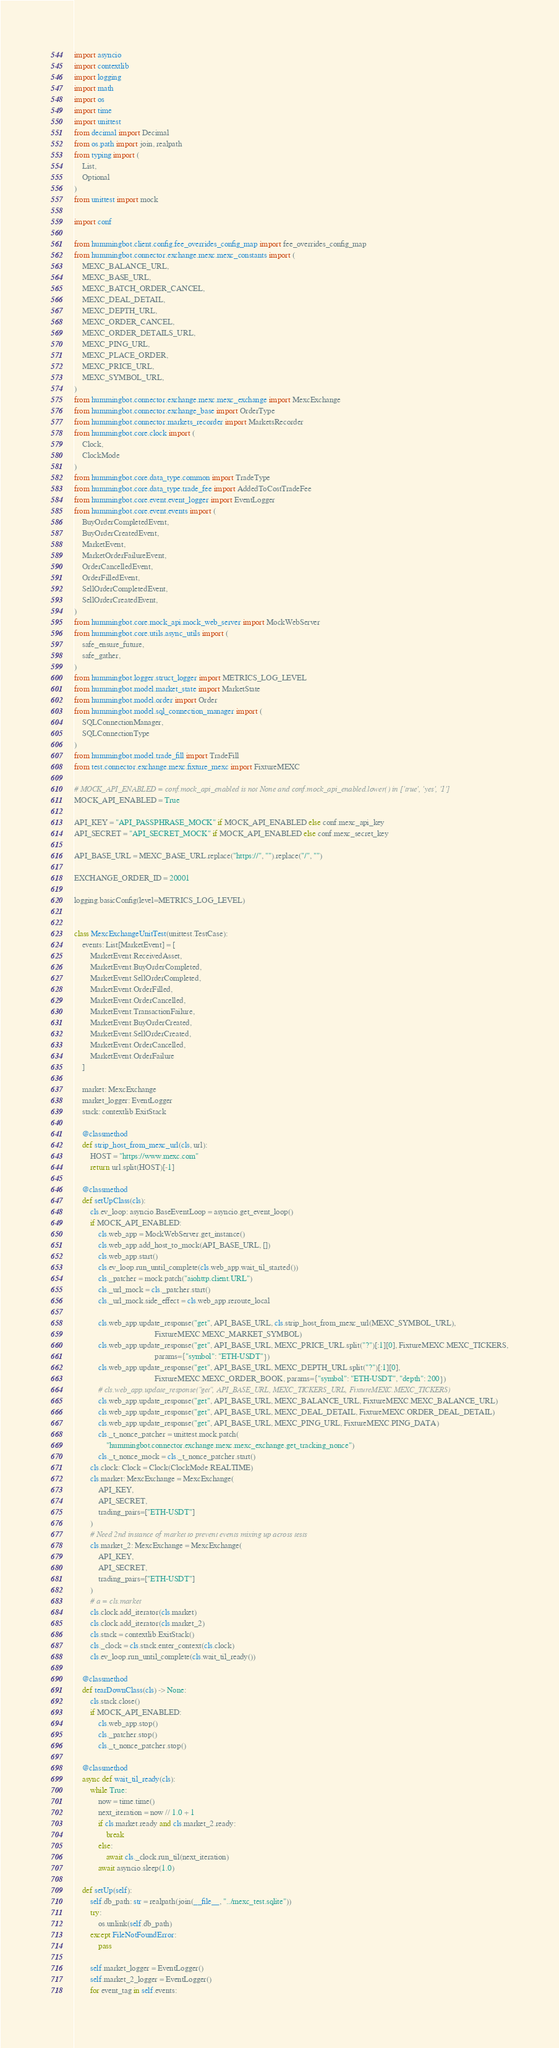<code> <loc_0><loc_0><loc_500><loc_500><_Python_>import asyncio
import contextlib
import logging
import math
import os
import time
import unittest
from decimal import Decimal
from os.path import join, realpath
from typing import (
    List,
    Optional
)
from unittest import mock

import conf

from hummingbot.client.config.fee_overrides_config_map import fee_overrides_config_map
from hummingbot.connector.exchange.mexc.mexc_constants import (
    MEXC_BALANCE_URL,
    MEXC_BASE_URL,
    MEXC_BATCH_ORDER_CANCEL,
    MEXC_DEAL_DETAIL,
    MEXC_DEPTH_URL,
    MEXC_ORDER_CANCEL,
    MEXC_ORDER_DETAILS_URL,
    MEXC_PING_URL,
    MEXC_PLACE_ORDER,
    MEXC_PRICE_URL,
    MEXC_SYMBOL_URL,
)
from hummingbot.connector.exchange.mexc.mexc_exchange import MexcExchange
from hummingbot.connector.exchange_base import OrderType
from hummingbot.connector.markets_recorder import MarketsRecorder
from hummingbot.core.clock import (
    Clock,
    ClockMode
)
from hummingbot.core.data_type.common import TradeType
from hummingbot.core.data_type.trade_fee import AddedToCostTradeFee
from hummingbot.core.event.event_logger import EventLogger
from hummingbot.core.event.events import (
    BuyOrderCompletedEvent,
    BuyOrderCreatedEvent,
    MarketEvent,
    MarketOrderFailureEvent,
    OrderCancelledEvent,
    OrderFilledEvent,
    SellOrderCompletedEvent,
    SellOrderCreatedEvent,
)
from hummingbot.core.mock_api.mock_web_server import MockWebServer
from hummingbot.core.utils.async_utils import (
    safe_ensure_future,
    safe_gather,
)
from hummingbot.logger.struct_logger import METRICS_LOG_LEVEL
from hummingbot.model.market_state import MarketState
from hummingbot.model.order import Order
from hummingbot.model.sql_connection_manager import (
    SQLConnectionManager,
    SQLConnectionType
)
from hummingbot.model.trade_fill import TradeFill
from test.connector.exchange.mexc.fixture_mexc import FixtureMEXC

# MOCK_API_ENABLED = conf.mock_api_enabled is not None and conf.mock_api_enabled.lower() in ['true', 'yes', '1']
MOCK_API_ENABLED = True

API_KEY = "API_PASSPHRASE_MOCK" if MOCK_API_ENABLED else conf.mexc_api_key
API_SECRET = "API_SECRET_MOCK" if MOCK_API_ENABLED else conf.mexc_secret_key

API_BASE_URL = MEXC_BASE_URL.replace("https://", "").replace("/", "")

EXCHANGE_ORDER_ID = 20001

logging.basicConfig(level=METRICS_LOG_LEVEL)


class MexcExchangeUnitTest(unittest.TestCase):
    events: List[MarketEvent] = [
        MarketEvent.ReceivedAsset,
        MarketEvent.BuyOrderCompleted,
        MarketEvent.SellOrderCompleted,
        MarketEvent.OrderFilled,
        MarketEvent.OrderCancelled,
        MarketEvent.TransactionFailure,
        MarketEvent.BuyOrderCreated,
        MarketEvent.SellOrderCreated,
        MarketEvent.OrderCancelled,
        MarketEvent.OrderFailure
    ]

    market: MexcExchange
    market_logger: EventLogger
    stack: contextlib.ExitStack

    @classmethod
    def strip_host_from_mexc_url(cls, url):
        HOST = "https://www.mexc.com"
        return url.split(HOST)[-1]

    @classmethod
    def setUpClass(cls):
        cls.ev_loop: asyncio.BaseEventLoop = asyncio.get_event_loop()
        if MOCK_API_ENABLED:
            cls.web_app = MockWebServer.get_instance()
            cls.web_app.add_host_to_mock(API_BASE_URL, [])
            cls.web_app.start()
            cls.ev_loop.run_until_complete(cls.web_app.wait_til_started())
            cls._patcher = mock.patch("aiohttp.client.URL")
            cls._url_mock = cls._patcher.start()
            cls._url_mock.side_effect = cls.web_app.reroute_local

            cls.web_app.update_response("get", API_BASE_URL, cls.strip_host_from_mexc_url(MEXC_SYMBOL_URL),
                                        FixtureMEXC.MEXC_MARKET_SYMBOL)
            cls.web_app.update_response("get", API_BASE_URL, MEXC_PRICE_URL.split("?")[:1][0], FixtureMEXC.MEXC_TICKERS,
                                        params={"symbol": "ETH-USDT"})
            cls.web_app.update_response("get", API_BASE_URL, MEXC_DEPTH_URL.split("?")[:1][0],
                                        FixtureMEXC.MEXC_ORDER_BOOK, params={"symbol": "ETH-USDT", "depth": 200})
            # cls.web_app.update_response("get", API_BASE_URL, MEXC_TICKERS_URL, FixtureMEXC.MEXC_TICKERS)
            cls.web_app.update_response("get", API_BASE_URL, MEXC_BALANCE_URL, FixtureMEXC.MEXC_BALANCE_URL)
            cls.web_app.update_response("get", API_BASE_URL, MEXC_DEAL_DETAIL, FixtureMEXC.ORDER_DEAL_DETAIL)
            cls.web_app.update_response("get", API_BASE_URL, MEXC_PING_URL, FixtureMEXC.PING_DATA)
            cls._t_nonce_patcher = unittest.mock.patch(
                "hummingbot.connector.exchange.mexc.mexc_exchange.get_tracking_nonce")
            cls._t_nonce_mock = cls._t_nonce_patcher.start()
        cls.clock: Clock = Clock(ClockMode.REALTIME)
        cls.market: MexcExchange = MexcExchange(
            API_KEY,
            API_SECRET,
            trading_pairs=["ETH-USDT"]
        )
        # Need 2nd instance of market to prevent events mixing up across tests
        cls.market_2: MexcExchange = MexcExchange(
            API_KEY,
            API_SECRET,
            trading_pairs=["ETH-USDT"]
        )
        # a = cls.market
        cls.clock.add_iterator(cls.market)
        cls.clock.add_iterator(cls.market_2)
        cls.stack = contextlib.ExitStack()
        cls._clock = cls.stack.enter_context(cls.clock)
        cls.ev_loop.run_until_complete(cls.wait_til_ready())

    @classmethod
    def tearDownClass(cls) -> None:
        cls.stack.close()
        if MOCK_API_ENABLED:
            cls.web_app.stop()
            cls._patcher.stop()
            cls._t_nonce_patcher.stop()

    @classmethod
    async def wait_til_ready(cls):
        while True:
            now = time.time()
            next_iteration = now // 1.0 + 1
            if cls.market.ready and cls.market_2.ready:
                break
            else:
                await cls._clock.run_til(next_iteration)
            await asyncio.sleep(1.0)

    def setUp(self):
        self.db_path: str = realpath(join(__file__, "../mexc_test.sqlite"))
        try:
            os.unlink(self.db_path)
        except FileNotFoundError:
            pass

        self.market_logger = EventLogger()
        self.market_2_logger = EventLogger()
        for event_tag in self.events:</code> 